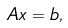<formula> <loc_0><loc_0><loc_500><loc_500>{ A } { x } = { b } ,</formula> 